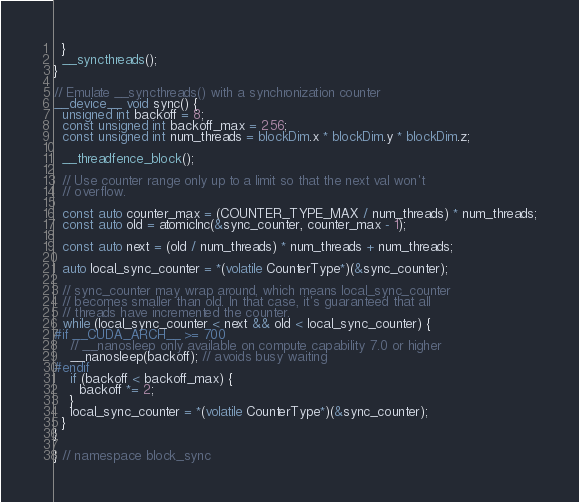Convert code to text. <code><loc_0><loc_0><loc_500><loc_500><_Cuda_>  }
  __syncthreads();
}

// Emulate __syncthreads() with a synchronization counter
__device__ void sync() {
  unsigned int backoff = 8;
  const unsigned int backoff_max = 256;
  const unsigned int num_threads = blockDim.x * blockDim.y * blockDim.z;

  __threadfence_block();

  // Use counter range only up to a limit so that the next val won't
  // overflow.

  const auto counter_max = (COUNTER_TYPE_MAX / num_threads) * num_threads;
  const auto old = atomicInc(&sync_counter, counter_max - 1);

  const auto next = (old / num_threads) * num_threads + num_threads;

  auto local_sync_counter = *(volatile CounterType*)(&sync_counter);

  // sync_counter may wrap around, which means local_sync_counter
  // becomes smaller than old. In that case, it's guaranteed that all
  // threads have incremented the counter.
  while (local_sync_counter < next && old < local_sync_counter) {
#if __CUDA_ARCH__ >= 700
    // __nanosleep only available on compute capability 7.0 or higher
    __nanosleep(backoff); // avoids busy waiting
#endif
    if (backoff < backoff_max) {
      backoff *= 2;
    }
    local_sync_counter = *(volatile CounterType*)(&sync_counter);
  }
}

} // namespace block_sync
</code> 